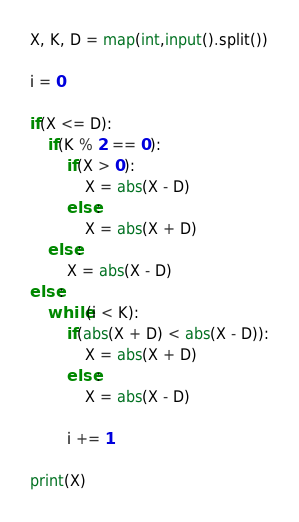Convert code to text. <code><loc_0><loc_0><loc_500><loc_500><_Python_>X, K, D = map(int,input().split())

i = 0

if(X <= D):
    if(K % 2 == 0):
        if(X > 0):
            X = abs(X - D)
        else:
            X = abs(X + D)
    else:
        X = abs(X - D)
else:
    while(i < K):
        if(abs(X + D) < abs(X - D)):
            X = abs(X + D)
        else:
            X = abs(X - D)
    
        i += 1

print(X)</code> 